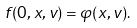Convert formula to latex. <formula><loc_0><loc_0><loc_500><loc_500>f ( 0 , x , v ) = \varphi ( x , v ) .</formula> 